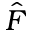<formula> <loc_0><loc_0><loc_500><loc_500>\hat { F }</formula> 